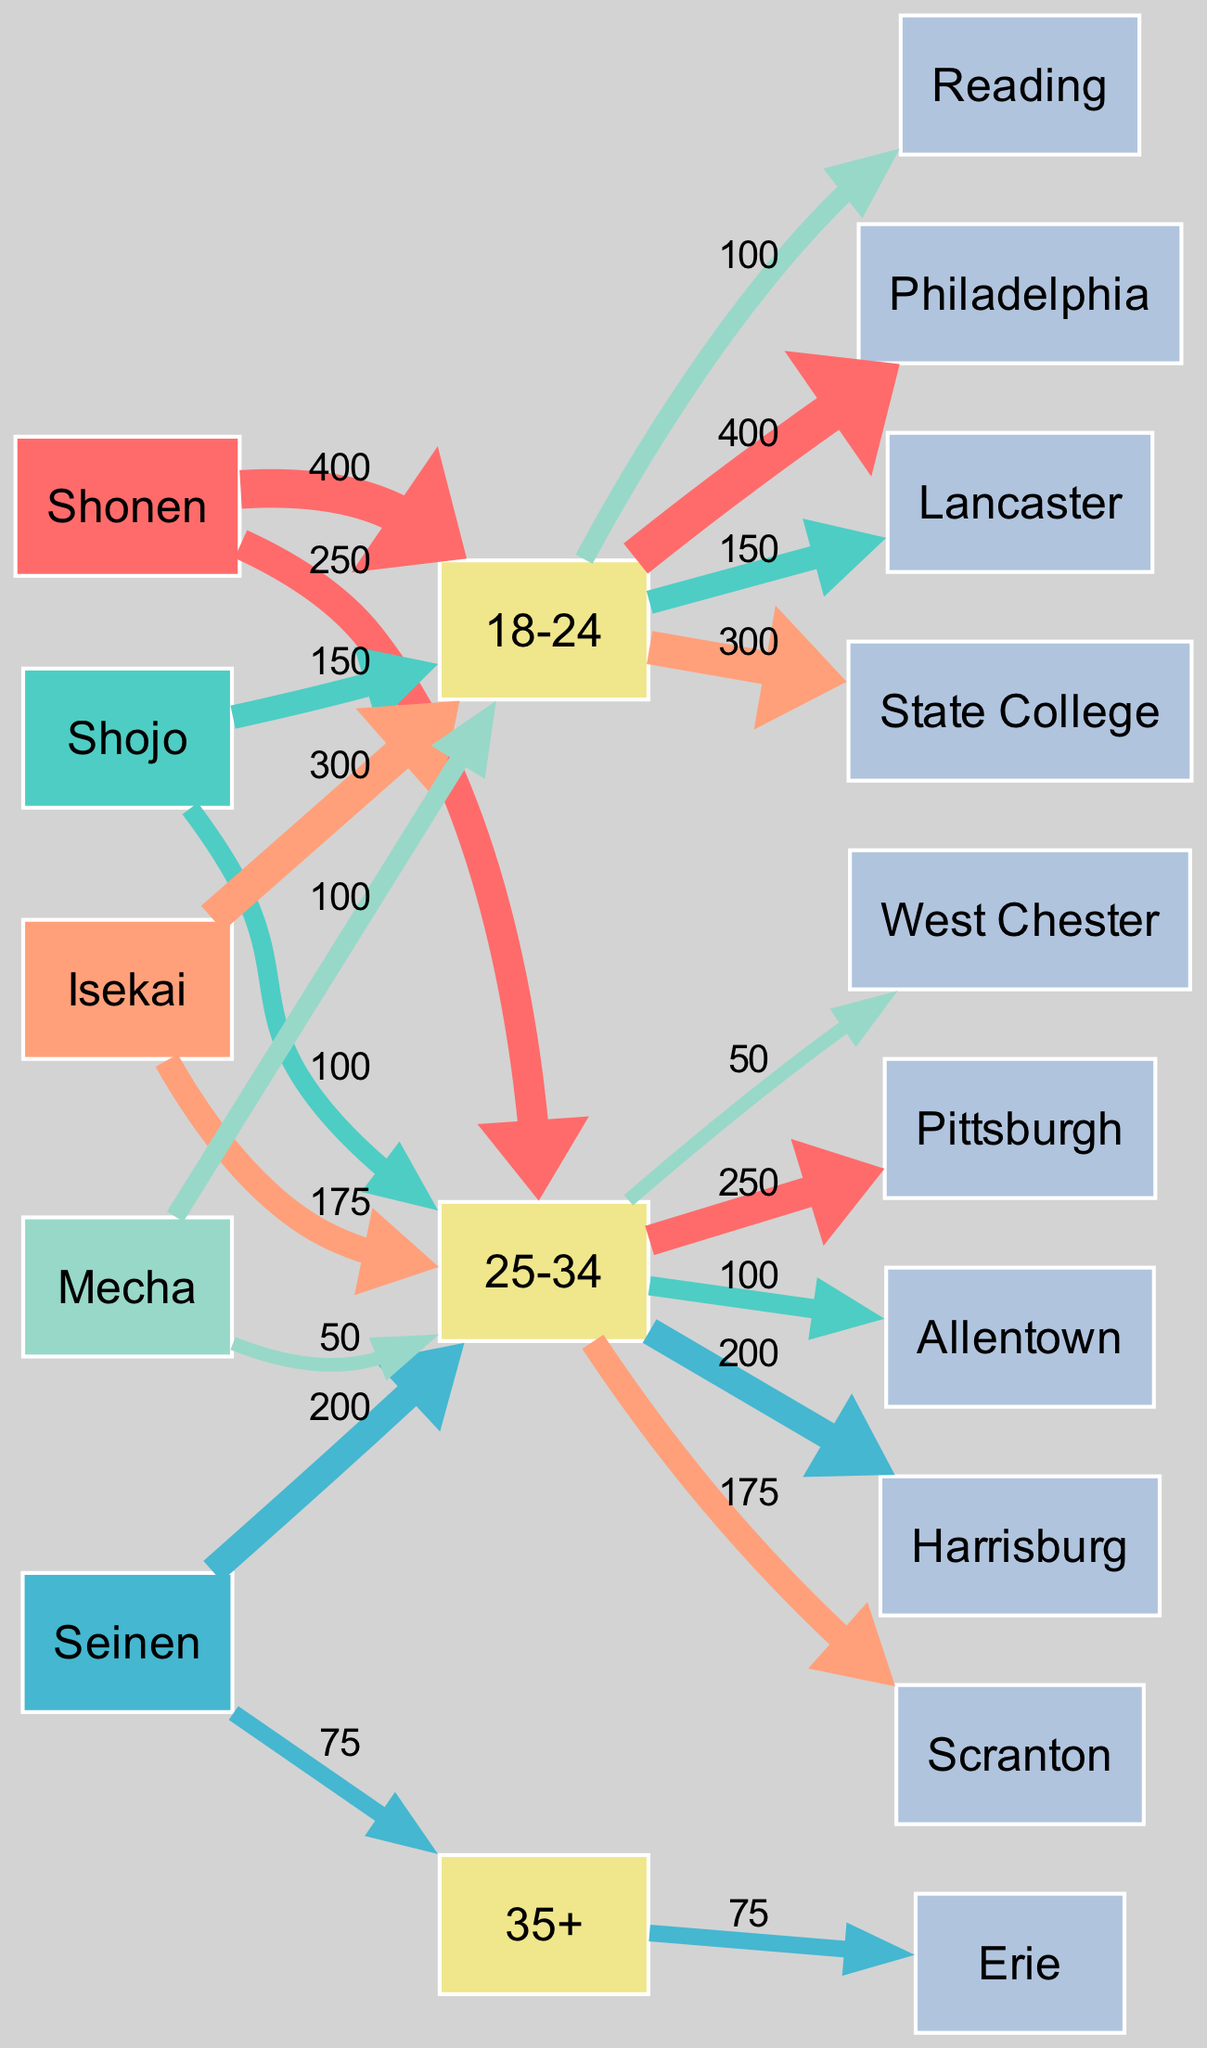What is the total count of participants in Shonen genre? In the diagram, "Shonen" has two age groups contributing to the count: 400 from 18-24 and 250 from 25-34. Therefore, the total count for "Shonen" is 400 + 250 = 650.
Answer: 650 Which age group has the highest count in the Isekai genre? The Isekai genre has two age groups with counts: 300 from 18-24 and 175 from 25-34. Since 300 is greater than 175, the age group with the highest count is 18-24.
Answer: 18-24 How many participants from Lancaster prefer Shojo? The diagram shows that in Lancaster, the count for the Shojo genre is 150 for the age group 18-24. Thus, the number of participants from Lancaster preferring Shojo is 150.
Answer: 150 In which location do the 25-34 year-olds prefer Seinen? The Seinen genre shows that for the 25-34 age group, the number of participants is 200 from Harrisburg. Therefore, the location for that age group is Harrisburg.
Answer: Harrisburg What is the lowest count genre among the 35+ age group? Looking at the diagram, the only genre for the 35+ age group is Seinen, which has a count of 75. Since this is the only entry for that age group, it is the lowest count genre for 35+.
Answer: Seinen Which genre has the second highest count for the 18-24 age group? In the 18-24 age group, the counts for genres are: Shonen (400), Isekai (300), and Mecha (100). The second highest count in this group is thus Isekai with 300 participants.
Answer: Isekai What percentage of total participants prefer Shonen? The total participants contributing across all genres equals 400 (Shonen) + 150 (Shojo) + 300 (Isekai) + 200 (Seinen) + 100 (Mecha) + 250 (Shonen) + 175 (Isekai) + 100 (Shojo) + 50 (Mecha) + 75 (Seinen) = 1850. Shonen count is 650. Thus, (650/1850) * 100 gives approximately 35.14%.
Answer: 35.14% How many different age groups prefer genre Mecha? In the Mecha genre, the age groups represented are 18-24 (count of 100) and 25-34 (count of 50). Thus, there are a total of 2 different age groups who prefer Mecha.
Answer: 2 Which two locations have the highest counts for the 18-24 age group? The 18-24 age group shows counts for Shonen (400 from Philadelphia) and Isekai (300 from State College), making these the two locations with the highest counts in that age range.
Answer: Philadelphia and State College How many edges are there leading from the Shojo genre to demographics? The Shojo genre connects to the 18-24 age group (150 from Lancaster) and the 25-34 age group (100 from Allentown), thus creating 2 edges leading from the Shojo genre to demographics.
Answer: 2 